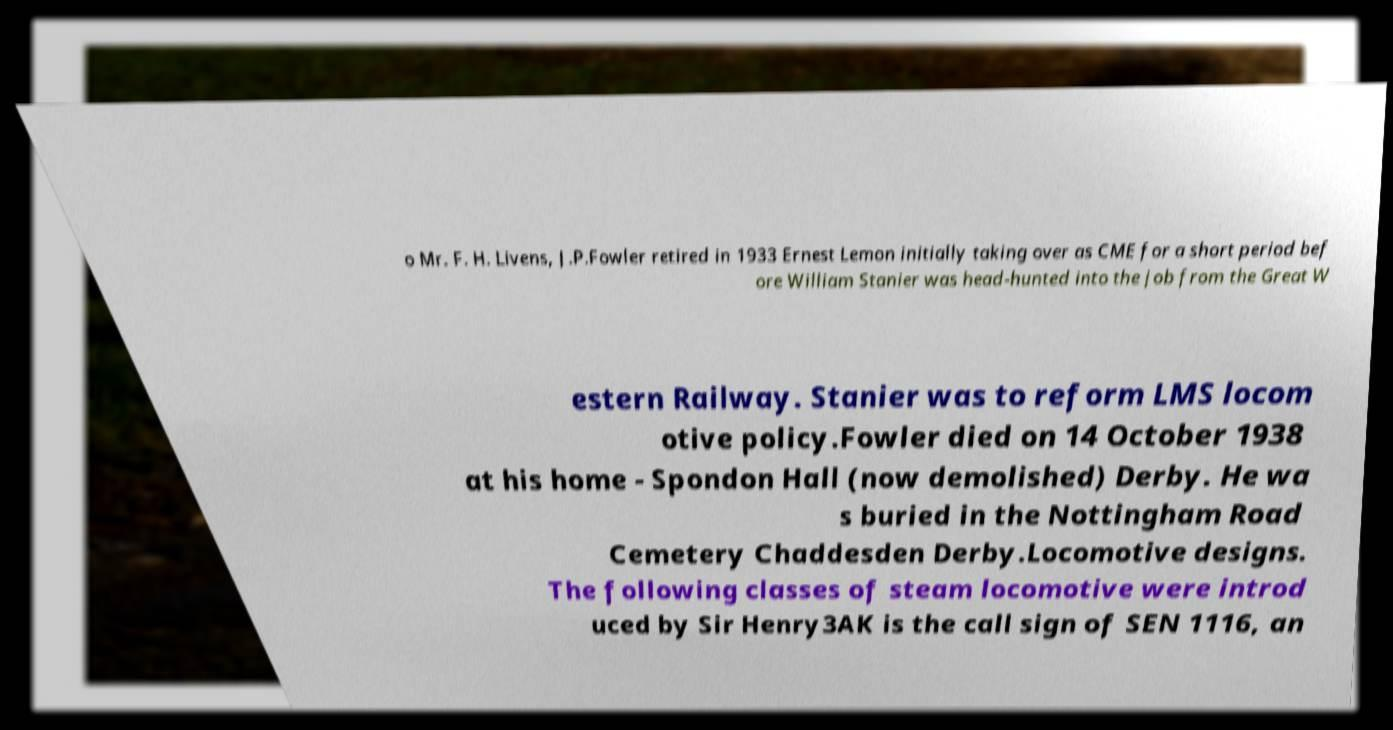Can you read and provide the text displayed in the image?This photo seems to have some interesting text. Can you extract and type it out for me? o Mr. F. H. Livens, J.P.Fowler retired in 1933 Ernest Lemon initially taking over as CME for a short period bef ore William Stanier was head-hunted into the job from the Great W estern Railway. Stanier was to reform LMS locom otive policy.Fowler died on 14 October 1938 at his home - Spondon Hall (now demolished) Derby. He wa s buried in the Nottingham Road Cemetery Chaddesden Derby.Locomotive designs. The following classes of steam locomotive were introd uced by Sir Henry3AK is the call sign of SEN 1116, an 